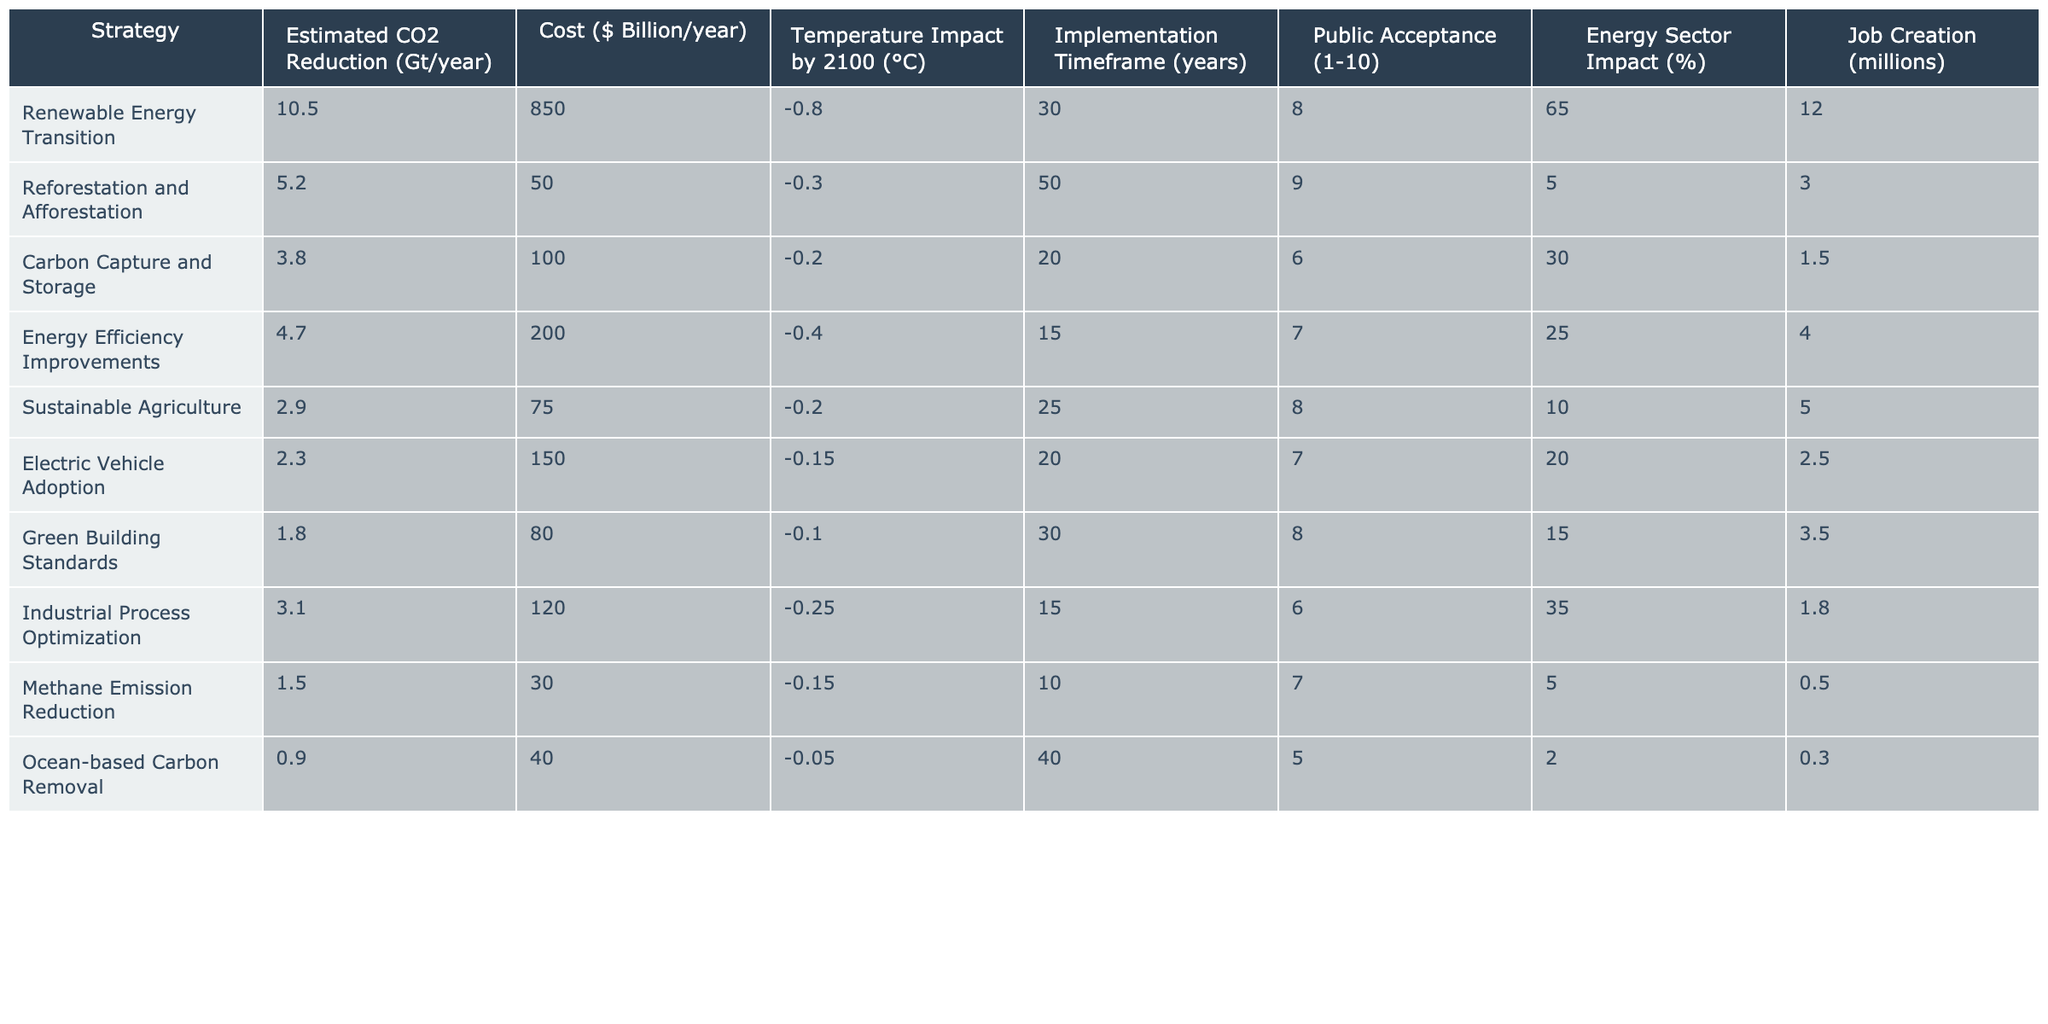What is the estimated CO2 reduction from the Renewable Energy Transition strategy? According to the table, the Renewable Energy Transition strategy has an estimated CO2 reduction of 10.5 Gt/year.
Answer: 10.5 Gt/year What is the cost of implementing the Carbon Capture and Storage strategy? The table indicates that the cost of the Carbon Capture and Storage strategy is $100 billion/year.
Answer: $100 billion/year Which strategy has the highest public acceptance rating? From the table, both Reforestation and Afforestation and Sustainable Agriculture have the highest public acceptance rating of 9.
Answer: 9 What is the total estimated CO2 reduction from the top three strategies? The top three strategies ranked by estimated CO2 reduction are Renewable Energy Transition (10.5 Gt/year), Reforestation and Afforestation (5.2 Gt/year), and Energy Efficiency Improvements (4.7 Gt/year). Adding these gives 10.5 + 5.2 + 4.7 = 20.4 Gt/year.
Answer: 20.4 Gt/year Does the Ocean-based Carbon Removal strategy contribute significantly to temperature reduction? The table shows that the Ocean-based Carbon Removal strategy has a temperature impact of -0.05 °C, which is relatively small compared to others.
Answer: No What is the average cost of the mitigation strategies listed in the table? To find the average cost, sum the costs of all strategies: 850 + 50 + 100 + 200 + 75 + 150 + 80 + 120 + 30 + 40 = 1,395 billion/year. There are 10 strategies, so the average cost is 1,395 / 10 = 139.5 billion/year.
Answer: $139.5 billion/year Which strategy has the longest implementation timeframe? The strategy with the longest implementation timeframe is Reforestation and Afforestation, which takes 50 years.
Answer: 50 years What is the difference in job creation between the Renewable Energy Transition and the Green Building Standards strategies? The job creation from the Renewable Energy Transition is 12 million, and from the Green Building Standards, it is 3.5 million. The difference is 12 - 3.5 = 8.5 million.
Answer: 8.5 million Which mitigation strategy has the least impact on the temperature rise by 2100? The strategy that contributes the least to the reduction of temperature rise is the Ocean-based Carbon Removal, with an impact of -0.05 °C.
Answer: Ocean-based Carbon Removal What is the relationship between public acceptance and estimated CO2 reduction for the provided strategies? Analyzing the table, higher public acceptance does not directly correlate with greater estimated CO2 reductions; for example, Renewable Energy Transition has high CO2 reduction but only an 8 for public acceptance.
Answer: No direct relationship 